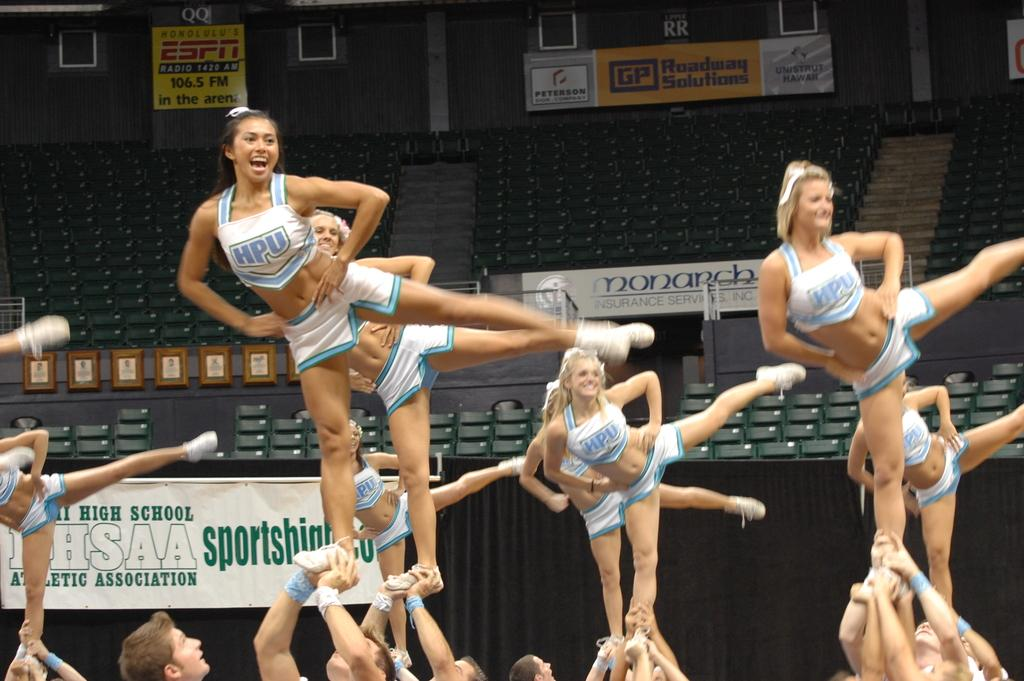What are the women in the image doing? The women in the image are dancing. How are the women being supported while dancing? Men are holding the women in the image. What can be seen on the walls in the background of the image? There are advertisements on the walls in the background of the image. What might be used for sitting or resting in the background of the image? There are seats in the background of the image. What type of flowers can be seen growing on the marble floor in the image? There are no flowers or marble floor present in the image. 